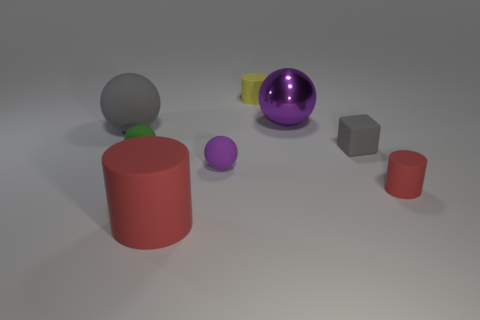Add 1 gray things. How many objects exist? 9 Subtract all cubes. How many objects are left? 7 Subtract all big spheres. Subtract all large yellow metallic blocks. How many objects are left? 6 Add 3 big objects. How many big objects are left? 6 Add 1 purple objects. How many purple objects exist? 3 Subtract 0 cyan balls. How many objects are left? 8 